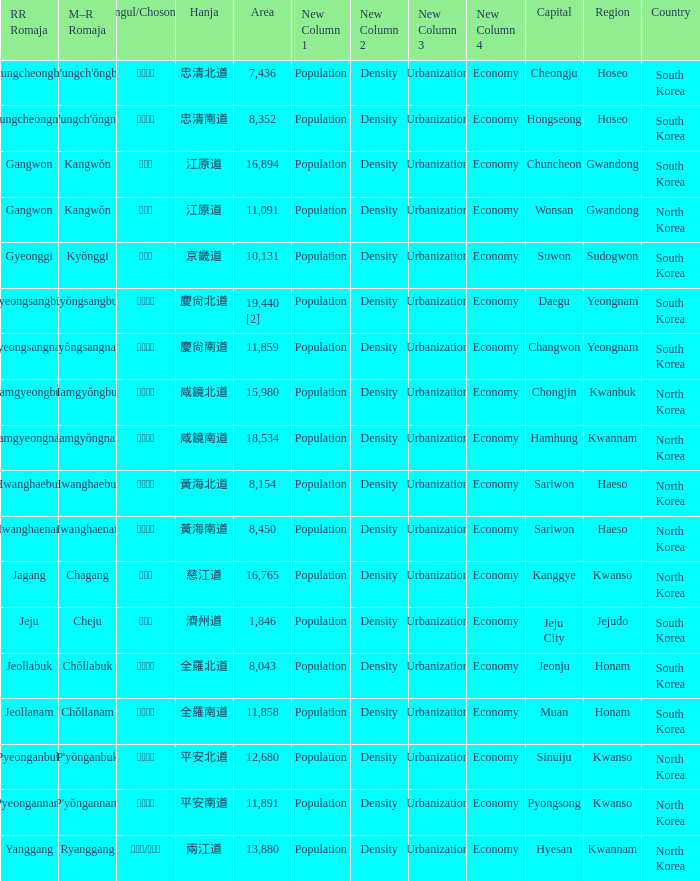What is the M-R Romaja for the province having a capital of Cheongju? Ch'ungch'ŏngbuk. 